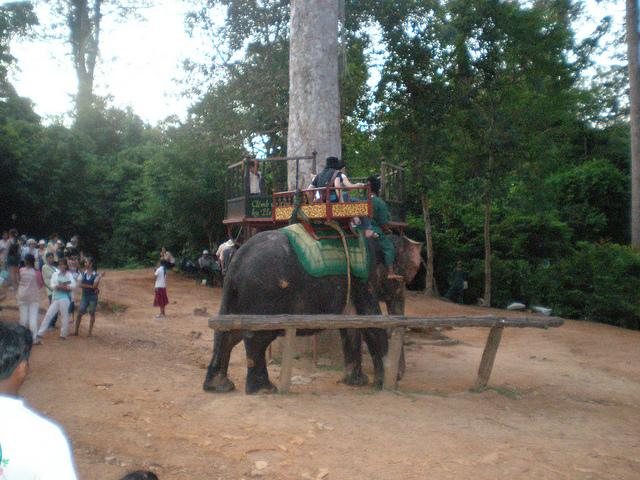What continent is this most likely? Please explain your reasoning. asia. This country is known for utilizing elephants as transportation in certain parts. the colors and fabrics used are also native of this country, and you can see features of the people that are common in this nationality. 